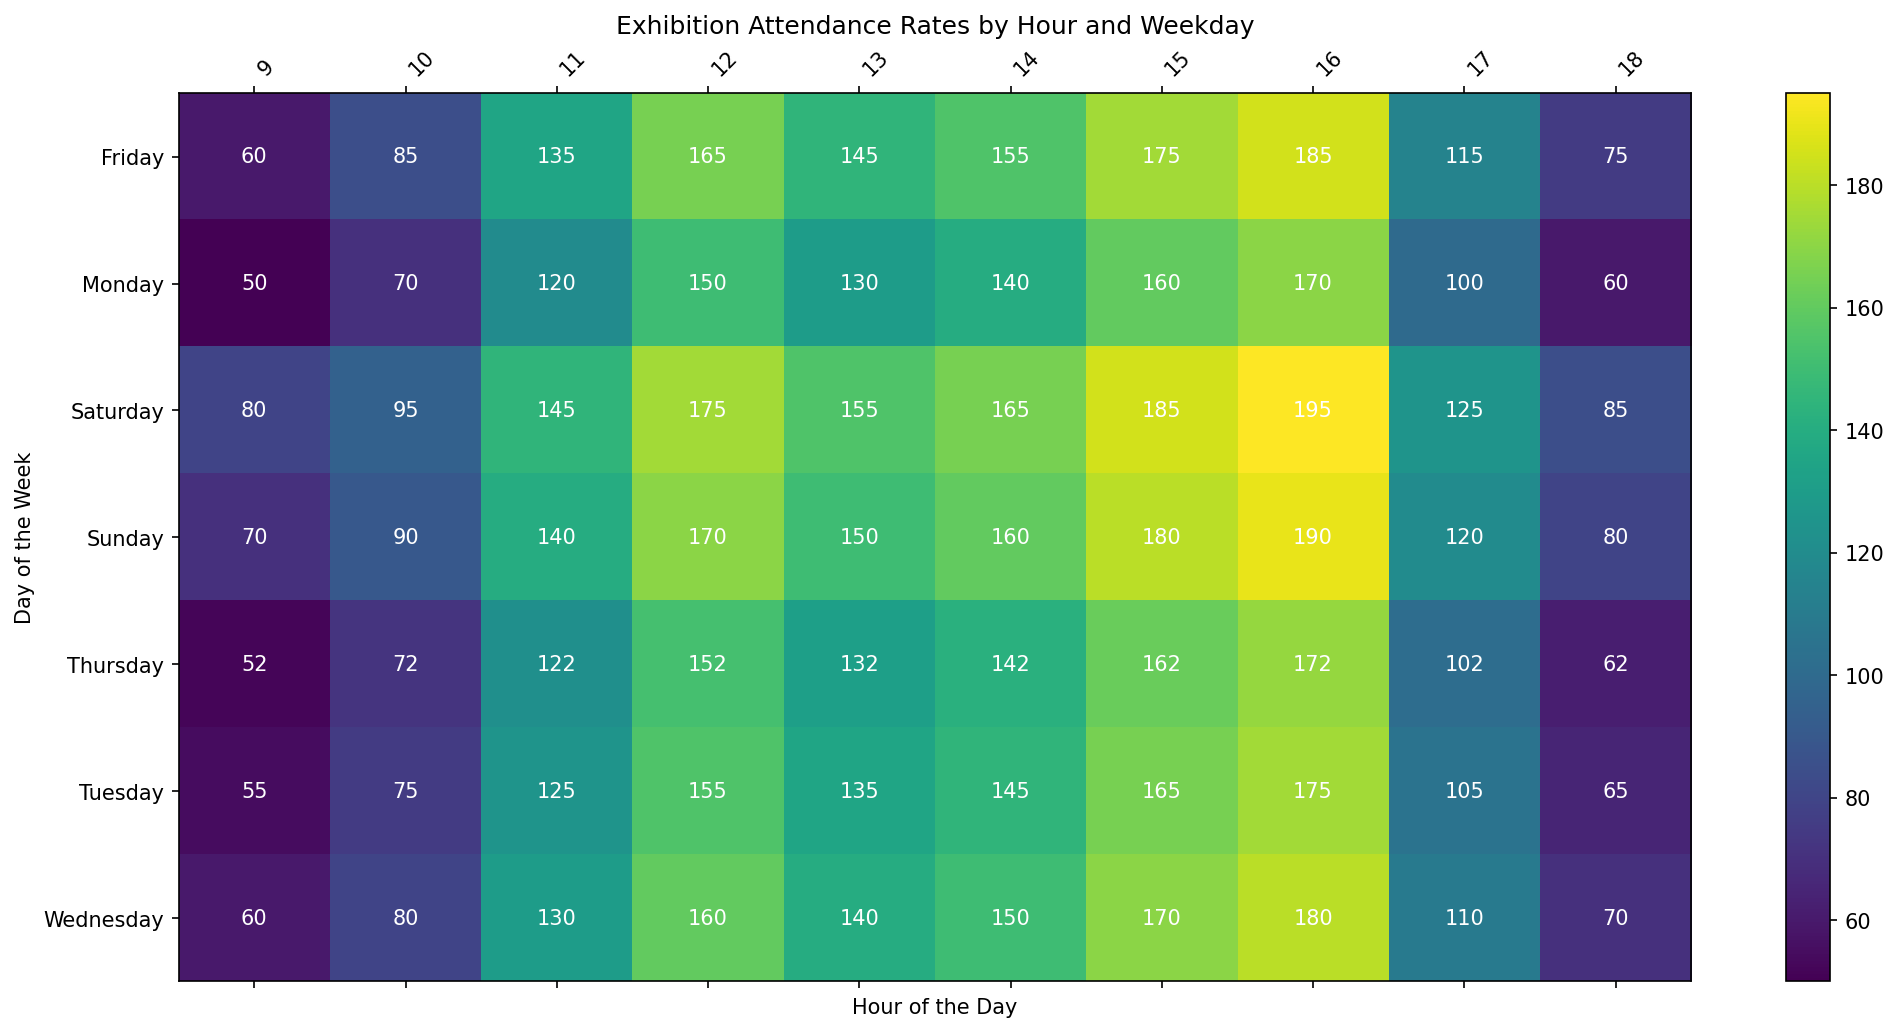what is the peak number of visitors on Saturday? First, look for Saturday on the y-axis. Then, check each value from 09 to 18. The highest value on Saturday is 195 at 16:00.
Answer: 195 Which day had the highest average attendance? To find the highest average attendance, sum the visitor numbers for each day and divide by the number of hours (10). Compare these averages for all days. The average values seem highest on Saturday.
Answer: Saturday How does the attendance at 12:00 on Friday compare to that on Tuesday? Locate the visitor numbers for 12:00 on both Friday and Tuesday from the heatmap. The value for Friday is 165 and for Tuesday is 155. Compare these numbers to see which is greater.
Answer: Higher on Friday What is the total number of visitors on Wednesday from 15:00 to 18:00? Sum the visitor numbers from 15:00 to 18:00 on Wednesday. The values are 170, 180, 110, and 70. Summing them up gives 170 + 180 + 110 + 70 = 530.
Answer: 530 Which hour of the day sees a consistent peak across all weekdays? Scan through each day from 09 to 18 and identify which hour consistently has high values. Typically, 16:00 appears consistently high across the data set.
Answer: 16:00 What is the range of attendance values on Monday? Find the minimum and maximum values for Monday. The minimum value is 50 at 09:00, and the maximum value is 170 at 16:00. The range is 170 - 50 = 120.
Answer: 120 Are there any hours where the attendance is below 60 on all days? Check each hour (from 09 to 18) across all days and see if any of these hours have values below 60. Notably, no such hour meets this condition.
Answer: No What is the median number of visitors at 15:00 across all days? List the visitor numbers at 15:00 for each day: 160, 165, 170, 162, 175, 185, 180. The median is the middle value when they are ordered: 160, 162, 165, 170, 175, 180, 185. The median is 170.
Answer: 170 What color corresponds to the visitor count of 175 on the heatmap? Identify the cells with the visitor count of 175. Observe the color in these cells aligned with the color bar. The corresponding color is a shade of light yellow.
Answer: Light yellow 